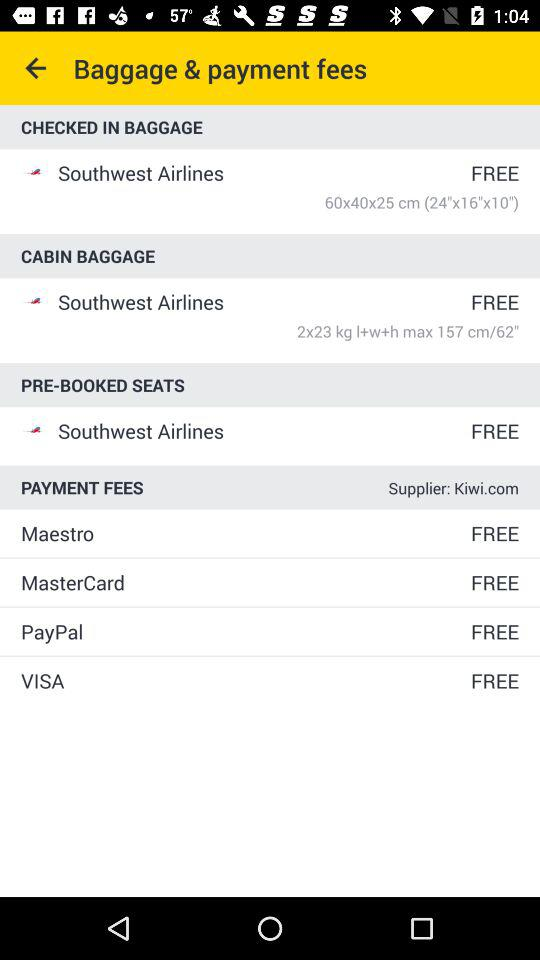What are the fees for cabin baggage on "Southwest Airlines"? The fees for cabin baggage on "Southwest Airlines" are free. 